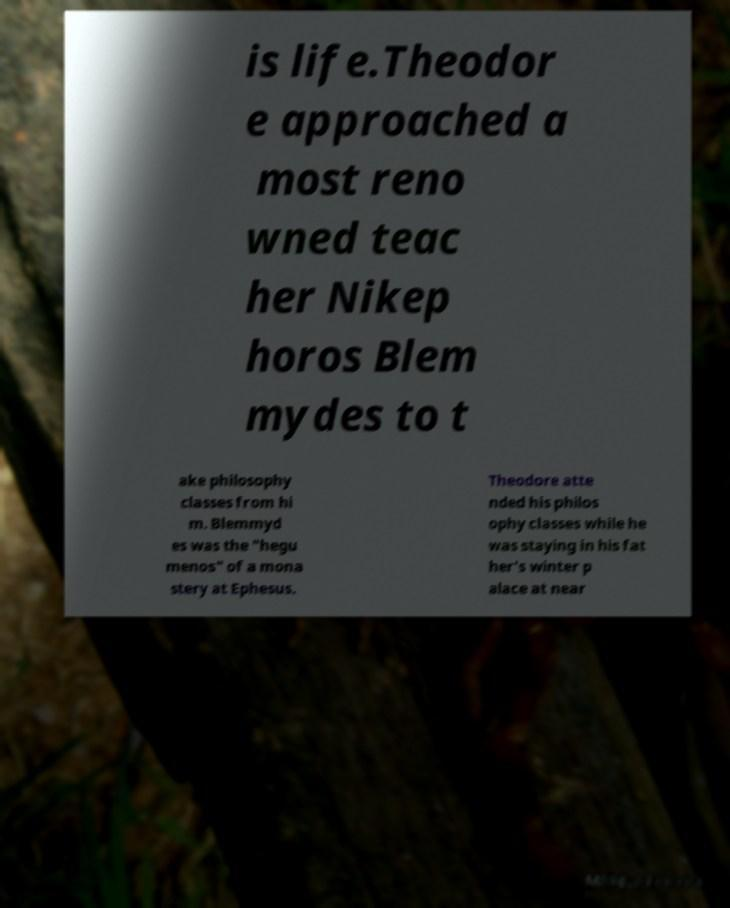Could you assist in decoding the text presented in this image and type it out clearly? is life.Theodor e approached a most reno wned teac her Nikep horos Blem mydes to t ake philosophy classes from hi m. Blemmyd es was the "hegu menos" of a mona stery at Ephesus. Theodore atte nded his philos ophy classes while he was staying in his fat her's winter p alace at near 